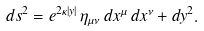Convert formula to latex. <formula><loc_0><loc_0><loc_500><loc_500>d s ^ { 2 } = e ^ { 2 \kappa | y | } \, \eta _ { \mu \nu } \, d x ^ { \mu } \, d x ^ { \nu } + d y ^ { 2 } .</formula> 